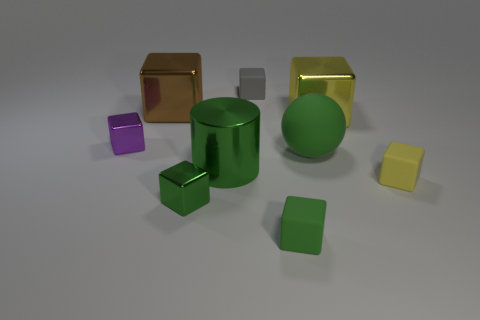How many things are either large green balls or metallic things?
Offer a very short reply. 6. There is a object behind the brown object; is it the same size as the big brown metal thing?
Keep it short and to the point. No. How big is the matte object that is in front of the yellow metal cube and left of the ball?
Offer a terse response. Small. How many other things are there of the same shape as the tiny yellow matte thing?
Keep it short and to the point. 6. How many other things are the same material as the small yellow block?
Provide a succinct answer. 3. There is a purple thing that is the same shape as the large yellow thing; what is its size?
Your answer should be compact. Small. Does the cylinder have the same color as the rubber sphere?
Your answer should be compact. Yes. What color is the small thing that is on the left side of the tiny gray object and in front of the yellow matte cube?
Your answer should be compact. Green. How many objects are either tiny objects in front of the green matte ball or big yellow metal cubes?
Your response must be concise. 4. There is another small shiny thing that is the same shape as the tiny purple object; what color is it?
Offer a terse response. Green. 